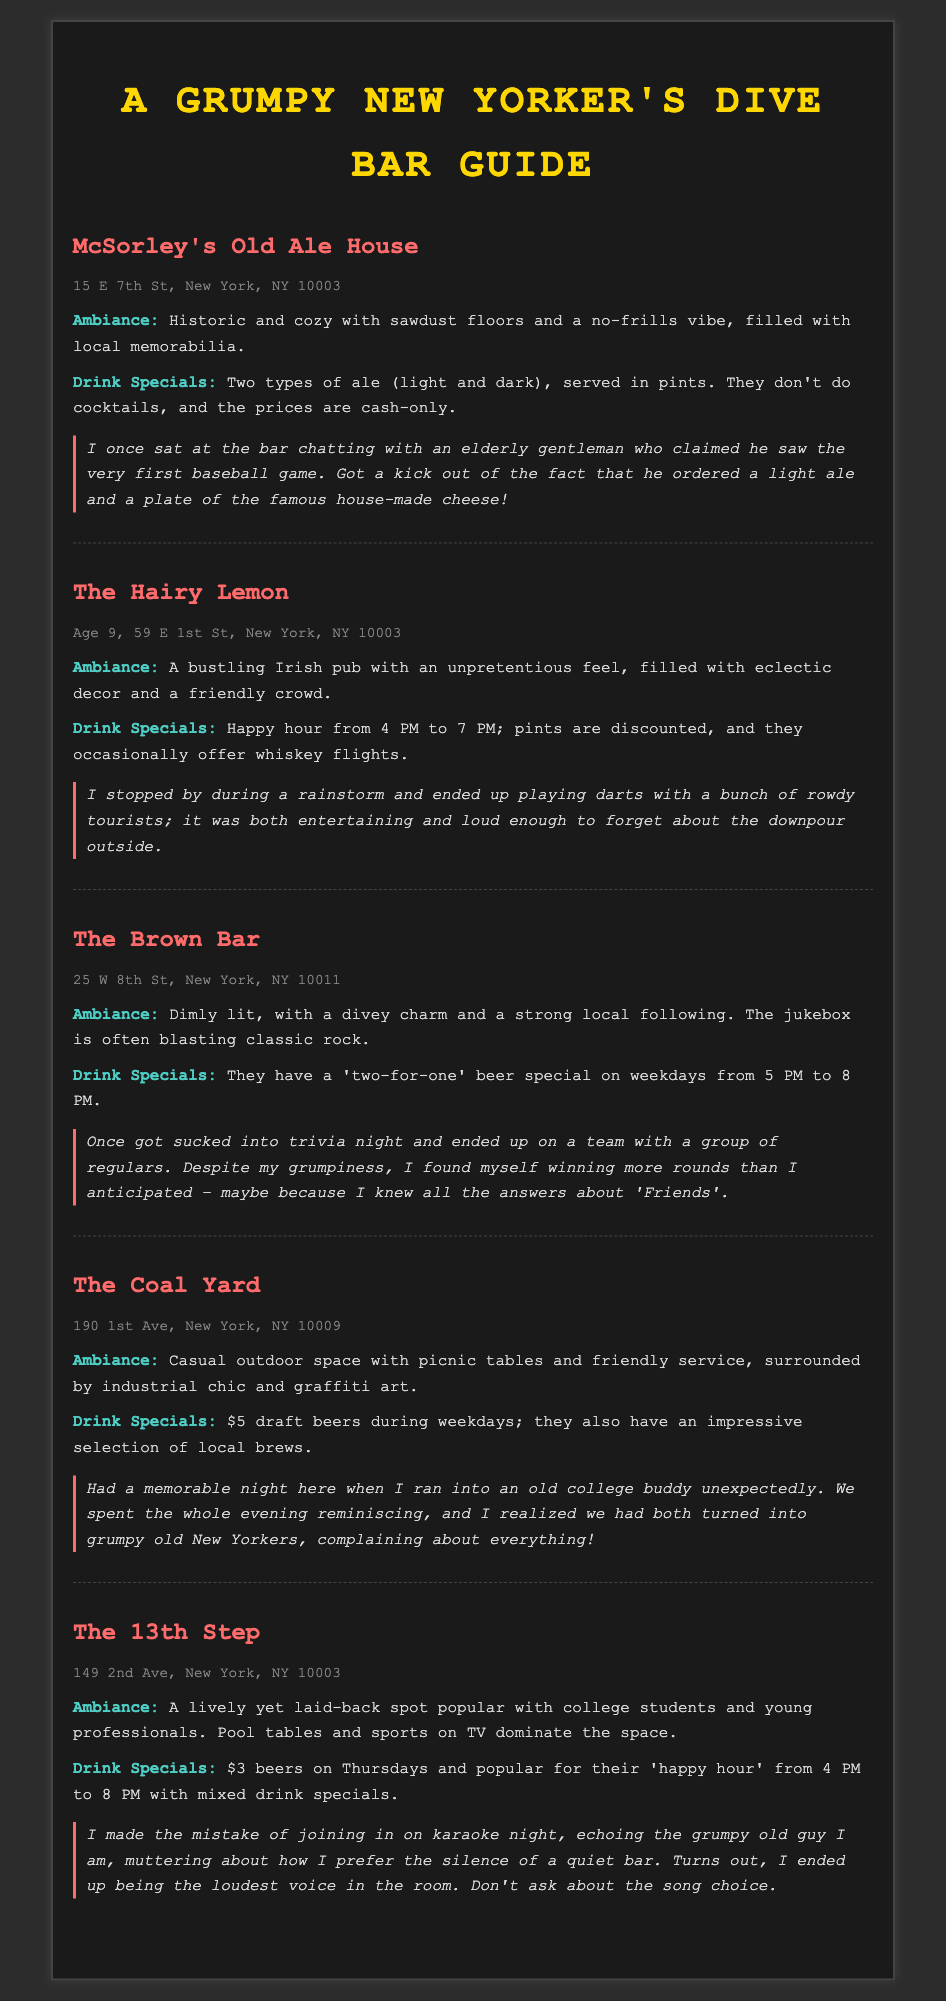What is the address of McSorley's Old Ale House? The address is stated in the document under the location section for McSorley's Old Ale House.
Answer: 15 E 7th St, New York, NY 10003 What drink special is offered at The 13th Step on Thursdays? The document mentions drink specials for specific days, highlighting the $3 beers on Thursdays at The 13th Step.
Answer: $3 beers How many ale types does McSorley's serve? The note specifies that McSorley's serves two types of ale, as outlined in their drink specials.
Answer: Two types What ambiance description fits The Coal Yard? The document provides an ambiance description for each bar, detailing The Coal Yard as "casual outdoor space with picnic tables".
Answer: Casual outdoor space What type of crowd does The Hairy Lemon attract? The document discusses the type of ambiance and crowd for each bar, indicating The Hairy Lemon is popular with a friendly crowd.
Answer: Friendly crowd Which bar has a trivia night? The document points out a personal experience regarding trivia night, specifically mentioning The Brown Bar.
Answer: The Brown Bar What is the drink special time for The Hairy Lemon? The document describes the happy hour at The Hairy Lemon and specifies the time it runs.
Answer: 4 PM to 7 PM Which location is known for karaoke nights? The document mentions a personal anecdote related to karaoke night at a specific bar.
Answer: The 13th Step 